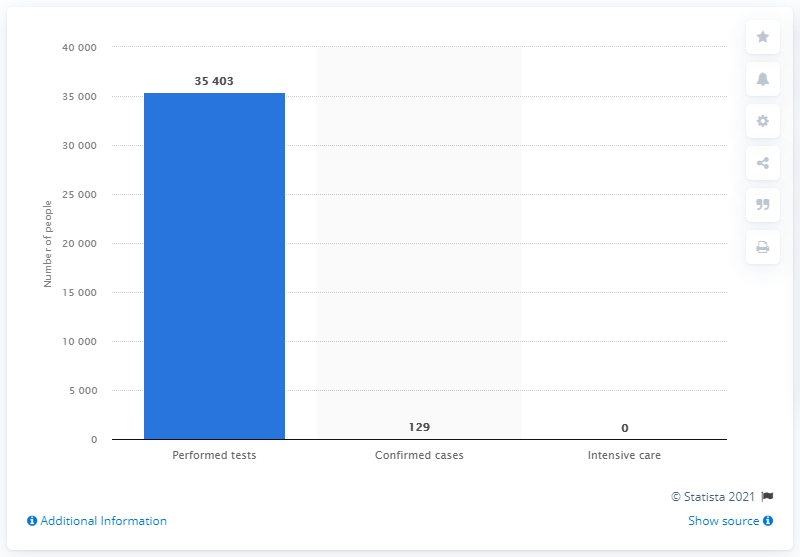Give some essential details in this illustration. On June 29, 2021, there were 129 confirmed cases of SARS-CoV-2 infections in New Caledonia. 